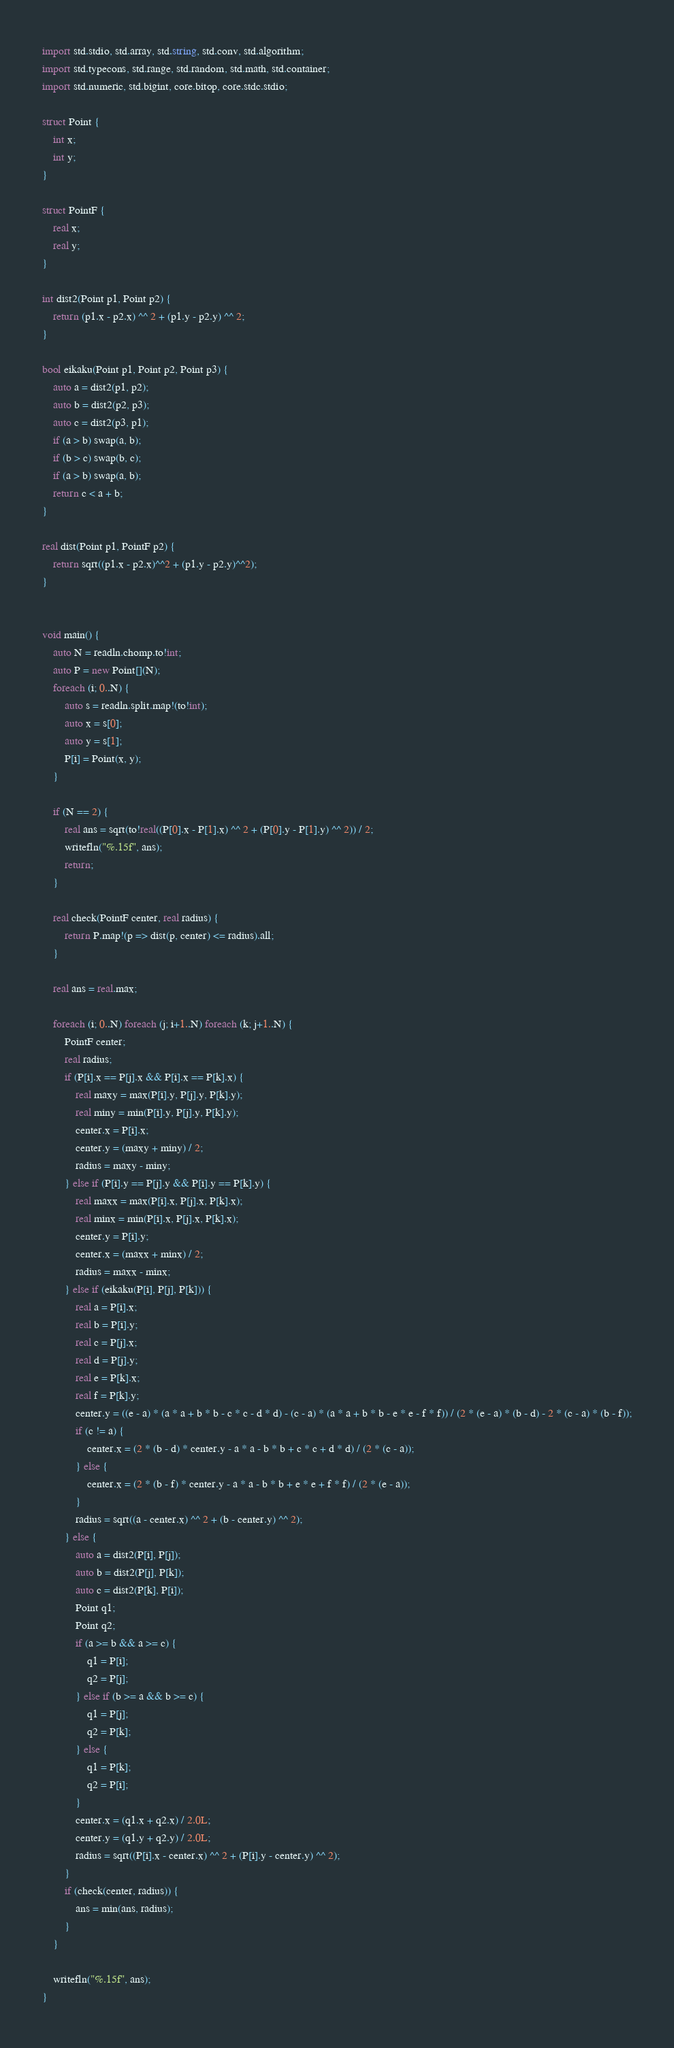<code> <loc_0><loc_0><loc_500><loc_500><_D_>import std.stdio, std.array, std.string, std.conv, std.algorithm;
import std.typecons, std.range, std.random, std.math, std.container;
import std.numeric, std.bigint, core.bitop, core.stdc.stdio;

struct Point {
    int x;
    int y;
}

struct PointF {
    real x;
    real y;
}

int dist2(Point p1, Point p2) {
    return (p1.x - p2.x) ^^ 2 + (p1.y - p2.y) ^^ 2;
}

bool eikaku(Point p1, Point p2, Point p3) {
    auto a = dist2(p1, p2);
    auto b = dist2(p2, p3);
    auto c = dist2(p3, p1);
    if (a > b) swap(a, b);
    if (b > c) swap(b, c);
    if (a > b) swap(a, b);
    return c < a + b;
}

real dist(Point p1, PointF p2) {
    return sqrt((p1.x - p2.x)^^2 + (p1.y - p2.y)^^2);
}


void main() {
    auto N = readln.chomp.to!int;
    auto P = new Point[](N);
    foreach (i; 0..N) {
        auto s = readln.split.map!(to!int);
        auto x = s[0];
        auto y = s[1];
        P[i] = Point(x, y);
    }

    if (N == 2) {
        real ans = sqrt(to!real((P[0].x - P[1].x) ^^ 2 + (P[0].y - P[1].y) ^^ 2)) / 2;
        writefln("%.15f", ans);
        return;
    }

    real check(PointF center, real radius) {
        return P.map!(p => dist(p, center) <= radius).all;
    }

    real ans = real.max;

    foreach (i; 0..N) foreach (j; i+1..N) foreach (k; j+1..N) {
        PointF center;
        real radius;
        if (P[i].x == P[j].x && P[i].x == P[k].x) {
            real maxy = max(P[i].y, P[j].y, P[k].y);
            real miny = min(P[i].y, P[j].y, P[k].y);
            center.x = P[i].x;
            center.y = (maxy + miny) / 2;
            radius = maxy - miny;
        } else if (P[i].y == P[j].y && P[i].y == P[k].y) {
            real maxx = max(P[i].x, P[j].x, P[k].x);
            real minx = min(P[i].x, P[j].x, P[k].x);
            center.y = P[i].y;
            center.x = (maxx + minx) / 2;
            radius = maxx - minx;
        } else if (eikaku(P[i], P[j], P[k])) {
            real a = P[i].x;
            real b = P[i].y;
            real c = P[j].x;
            real d = P[j].y;
            real e = P[k].x;
            real f = P[k].y;
            center.y = ((e - a) * (a * a + b * b - c * c - d * d) - (c - a) * (a * a + b * b - e * e - f * f)) / (2 * (e - a) * (b - d) - 2 * (c - a) * (b - f));
            if (c != a) {
                center.x = (2 * (b - d) * center.y - a * a - b * b + c * c + d * d) / (2 * (c - a));
            } else {
                center.x = (2 * (b - f) * center.y - a * a - b * b + e * e + f * f) / (2 * (e - a));
            }
            radius = sqrt((a - center.x) ^^ 2 + (b - center.y) ^^ 2);
        } else {
            auto a = dist2(P[i], P[j]);
            auto b = dist2(P[j], P[k]);
            auto c = dist2(P[k], P[i]);
            Point q1;
            Point q2;
            if (a >= b && a >= c) {
                q1 = P[i];
                q2 = P[j];
            } else if (b >= a && b >= c) {
                q1 = P[j];
                q2 = P[k];
            } else {
                q1 = P[k];
                q2 = P[i];
            }
            center.x = (q1.x + q2.x) / 2.0L;
            center.y = (q1.y + q2.y) / 2.0L;
            radius = sqrt((P[i].x - center.x) ^^ 2 + (P[i].y - center.y) ^^ 2);
        }
        if (check(center, radius)) {
            ans = min(ans, radius);
        }
    }

    writefln("%.15f", ans);
}</code> 